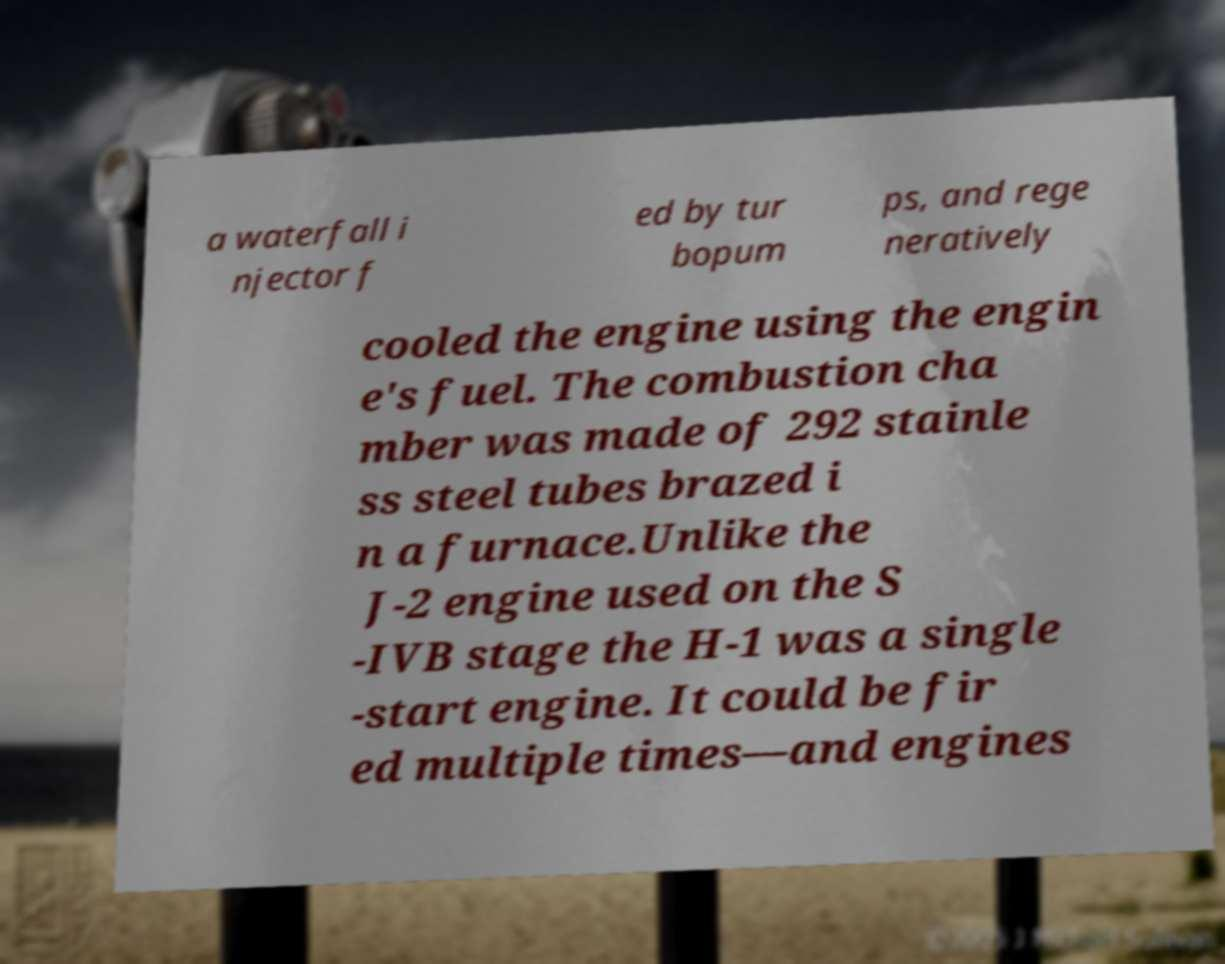Could you extract and type out the text from this image? a waterfall i njector f ed by tur bopum ps, and rege neratively cooled the engine using the engin e's fuel. The combustion cha mber was made of 292 stainle ss steel tubes brazed i n a furnace.Unlike the J-2 engine used on the S -IVB stage the H-1 was a single -start engine. It could be fir ed multiple times—and engines 